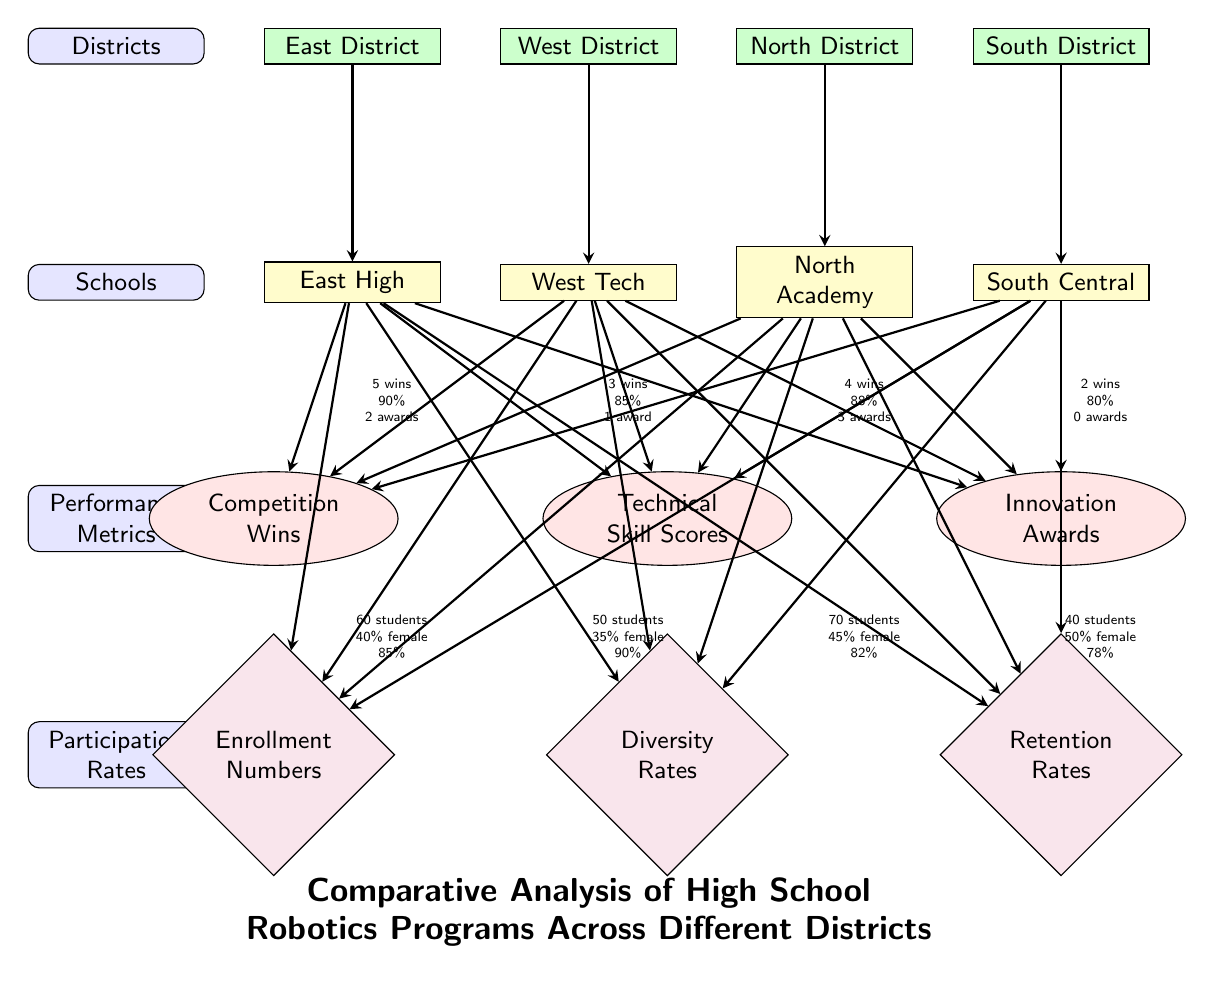What is the total number of districts represented in the diagram? The diagram features four district nodes, labeled East District, West District, North District, and South District. Counting these nodes gives a total of four.
Answer: 4 What school has the highest competition wins? Among the schools listed, East High is noted to have 5 competition wins, which is the highest compared to the other schools.
Answer: East High What is the retention rate for North Academy? The retention rate for North Academy, as indicated in the participation rates section, is 82%.
Answer: 82% Which district has the lowest diversity rate? The district with the lowest diversity rate is South District, represented by South Central, with a diversity rate of 40%.
Answer: 40% How many performance metrics are tracked in the diagram? The diagram lists three performance metrics: Competition Wins, Technical Skill Scores, and Innovation Awards. Counting these metrics gives a total of three.
Answer: 3 What is the technical skill score for West Tech? West Tech has a technical skill score of 85%, as indicated in the performance metrics section related to that school.
Answer: 85% Which school has the highest enrollment number? The school with the highest enrollment number is North Academy, which has 70 students enrolled.
Answer: 70 students What do the metrics "Competition Wins" and "Retention Rates" represent in the context of this diagram? "Competition Wins" indicates the success of each school's robotics program in competitions, while "Retention Rates" measures the percentage of students who continue participating in the program over time. Both metrics provide insights into the effectiveness and attractiveness of the programs.
Answer: Success and Engagement Which district has the highest number of technical skill scores? The district with the highest technical skill score is North District, associated with North Academy, which has a score of 88%.
Answer: 88% 